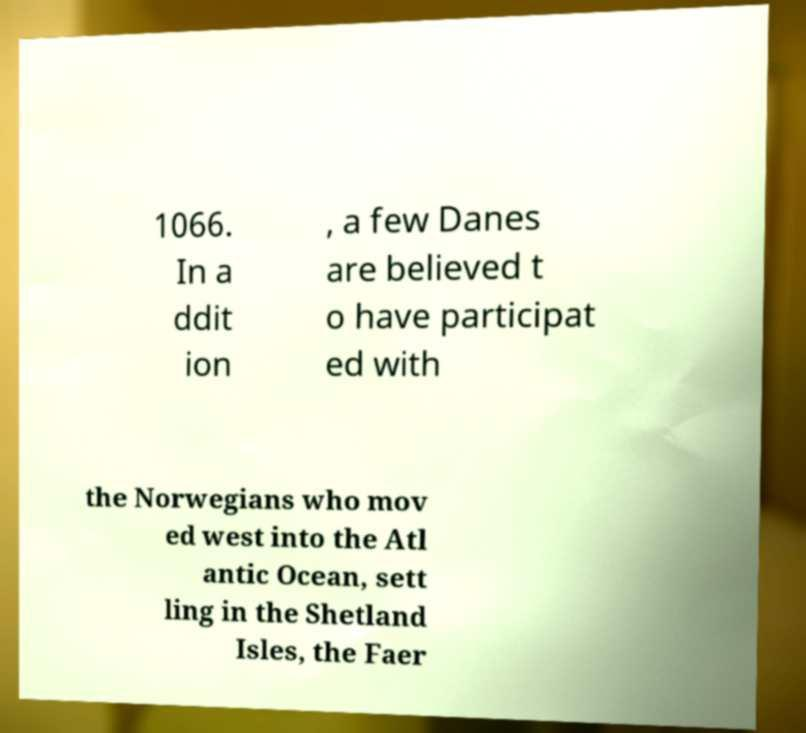There's text embedded in this image that I need extracted. Can you transcribe it verbatim? 1066. In a ddit ion , a few Danes are believed t o have participat ed with the Norwegians who mov ed west into the Atl antic Ocean, sett ling in the Shetland Isles, the Faer 